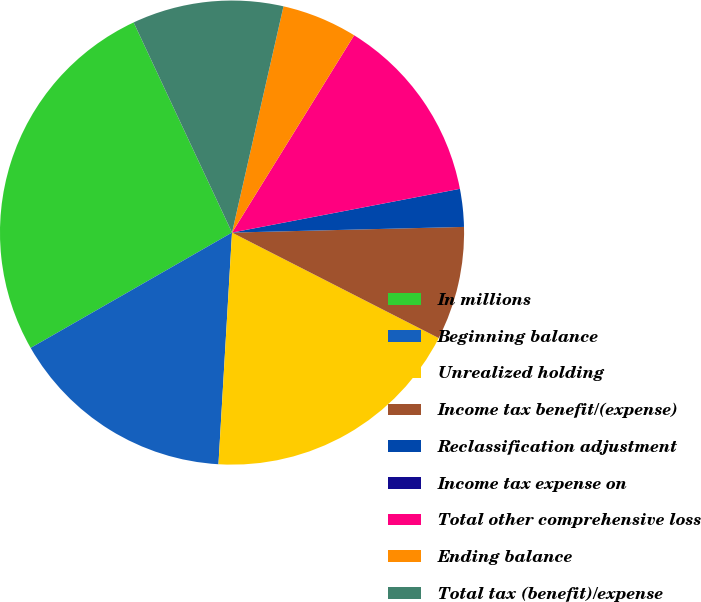Convert chart. <chart><loc_0><loc_0><loc_500><loc_500><pie_chart><fcel>In millions<fcel>Beginning balance<fcel>Unrealized holding<fcel>Income tax benefit/(expense)<fcel>Reclassification adjustment<fcel>Income tax expense on<fcel>Total other comprehensive loss<fcel>Ending balance<fcel>Total tax (benefit)/expense<nl><fcel>26.31%<fcel>15.79%<fcel>18.42%<fcel>7.9%<fcel>2.63%<fcel>0.0%<fcel>13.16%<fcel>5.26%<fcel>10.53%<nl></chart> 